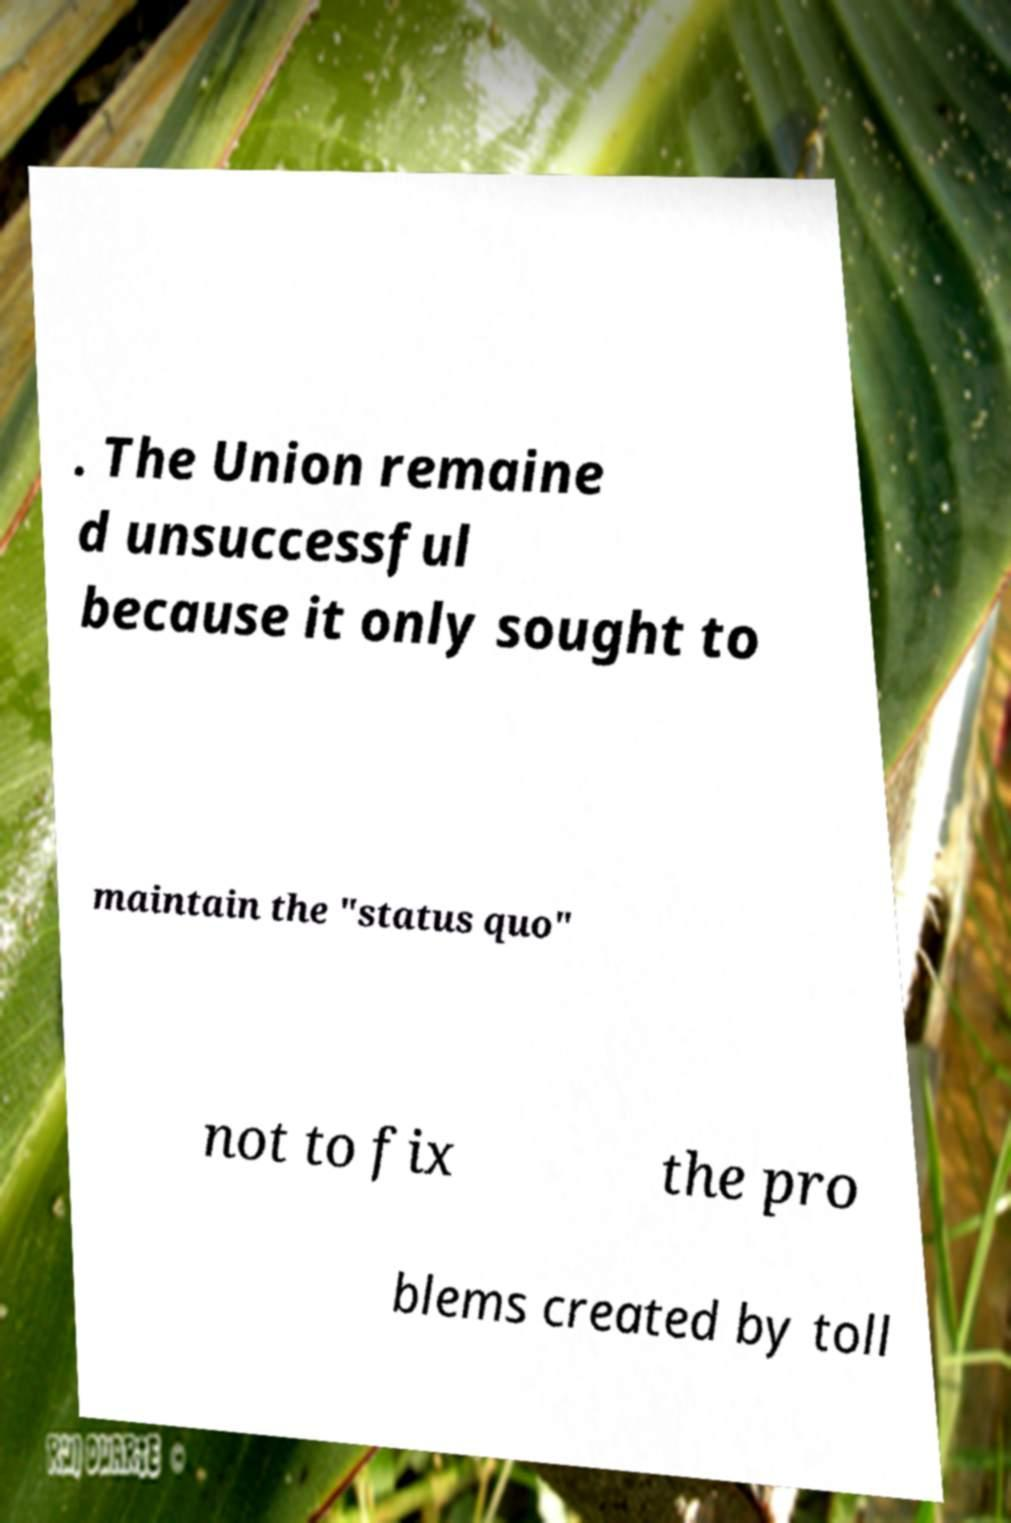There's text embedded in this image that I need extracted. Can you transcribe it verbatim? . The Union remaine d unsuccessful because it only sought to maintain the "status quo" not to fix the pro blems created by toll 